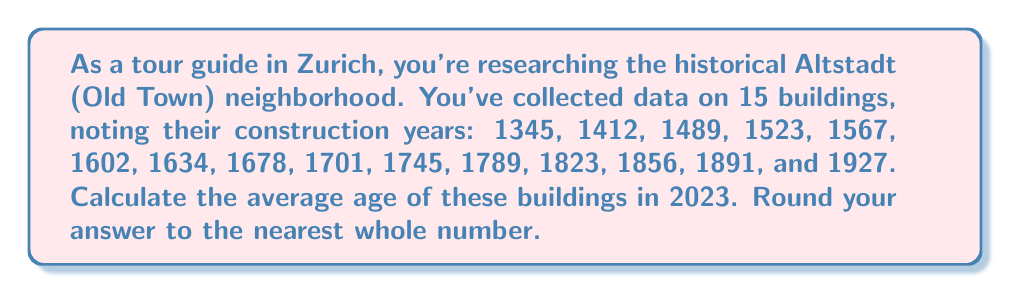Solve this math problem. To solve this problem, we'll follow these steps:

1) First, calculate the age of each building by subtracting its construction year from the current year (2023).

2) Sum up all the ages.

3) Divide the sum by the number of buildings to get the average.

4) Round the result to the nearest whole number.

Let's calculate:

1) Ages of buildings:
   $2023 - 1345 = 678$
   $2023 - 1412 = 611$
   $2023 - 1489 = 534$
   $2023 - 1523 = 500$
   $2023 - 1567 = 456$
   $2023 - 1602 = 421$
   $2023 - 1634 = 389$
   $2023 - 1678 = 345$
   $2023 - 1701 = 322$
   $2023 - 1745 = 278$
   $2023 - 1789 = 234$
   $2023 - 1823 = 200$
   $2023 - 1856 = 167$
   $2023 - 1891 = 132$
   $2023 - 1927 = 96$

2) Sum of ages:
   $678 + 611 + 534 + 500 + 456 + 421 + 389 + 345 + 322 + 278 + 234 + 200 + 167 + 132 + 96 = 5363$

3) Average age:
   $$\text{Average} = \frac{\text{Sum of ages}}{\text{Number of buildings}} = \frac{5363}{15} = 357.5333...$$ 

4) Rounding to the nearest whole number:
   $357.5333...$ rounds to $358$
Answer: The average age of the buildings is 358 years. 